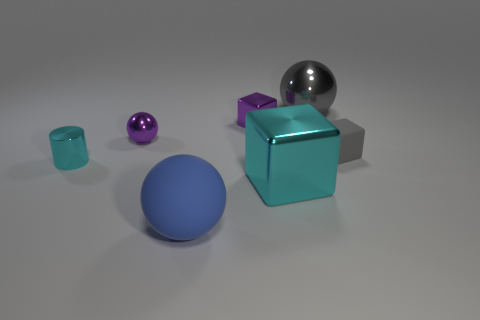What number of spheres are either small purple objects or large metallic things?
Offer a terse response. 2. Is the number of blue objects that are in front of the big blue rubber sphere the same as the number of big things?
Keep it short and to the point. No. What is the small block left of the gray shiny thing behind the small block on the left side of the gray matte cube made of?
Offer a very short reply. Metal. There is a small block that is the same color as the big shiny sphere; what is it made of?
Offer a terse response. Rubber. What number of objects are metallic blocks behind the tiny gray block or metallic balls?
Your answer should be compact. 3. How many objects are either large blue spheres or matte things that are in front of the gray cube?
Ensure brevity in your answer.  1. There is a big shiny object left of the large shiny object behind the cylinder; how many large objects are to the left of it?
Ensure brevity in your answer.  1. What is the material of the purple block that is the same size as the cylinder?
Your answer should be compact. Metal. Are there any cyan cubes that have the same size as the blue rubber object?
Provide a short and direct response. Yes. What is the color of the large metallic ball?
Offer a very short reply. Gray. 